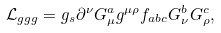<formula> <loc_0><loc_0><loc_500><loc_500>\mathcal { L } _ { g g g } = g _ { s } \partial ^ { \nu } G ^ { a } _ { \mu } g ^ { \mu \rho } f _ { a b c } G ^ { b } _ { \nu } G ^ { c } _ { \rho } ,</formula> 